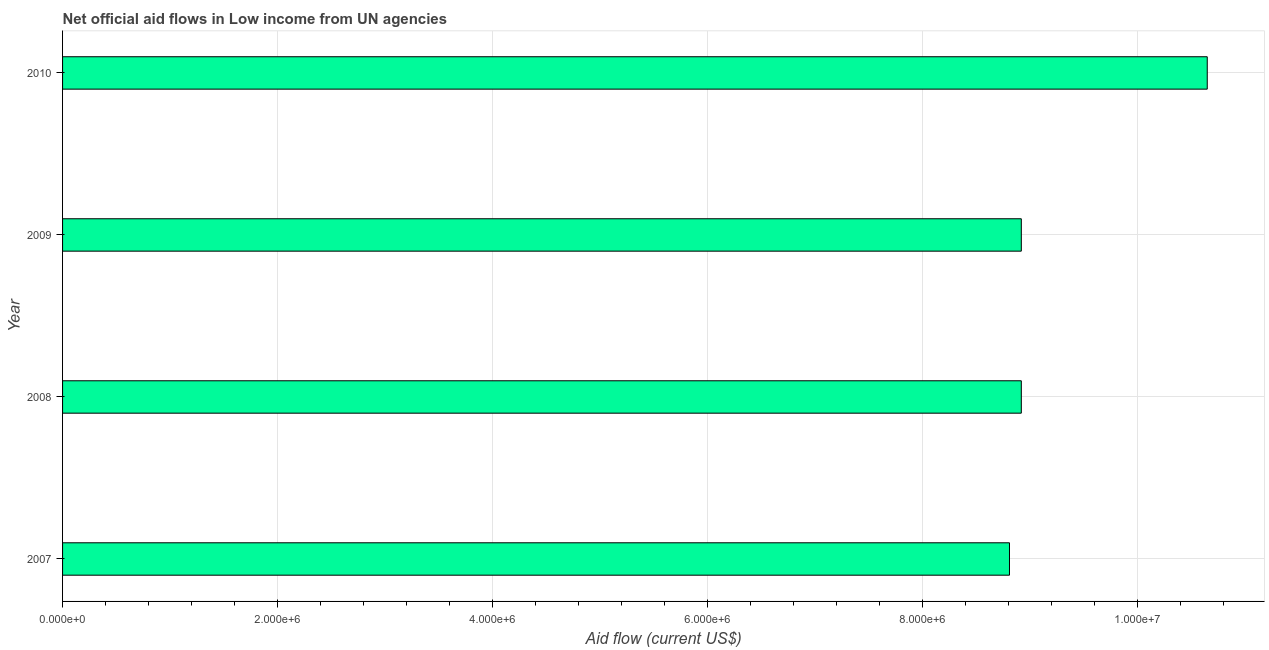What is the title of the graph?
Ensure brevity in your answer.  Net official aid flows in Low income from UN agencies. What is the net official flows from un agencies in 2008?
Offer a terse response. 8.92e+06. Across all years, what is the maximum net official flows from un agencies?
Provide a short and direct response. 1.06e+07. Across all years, what is the minimum net official flows from un agencies?
Provide a succinct answer. 8.81e+06. In which year was the net official flows from un agencies maximum?
Offer a very short reply. 2010. In which year was the net official flows from un agencies minimum?
Offer a terse response. 2007. What is the sum of the net official flows from un agencies?
Ensure brevity in your answer.  3.73e+07. What is the difference between the net official flows from un agencies in 2007 and 2010?
Provide a short and direct response. -1.84e+06. What is the average net official flows from un agencies per year?
Give a very brief answer. 9.32e+06. What is the median net official flows from un agencies?
Your answer should be compact. 8.92e+06. Do a majority of the years between 2009 and 2010 (inclusive) have net official flows from un agencies greater than 8400000 US$?
Give a very brief answer. Yes. What is the ratio of the net official flows from un agencies in 2007 to that in 2010?
Your response must be concise. 0.83. Is the net official flows from un agencies in 2007 less than that in 2010?
Make the answer very short. Yes. What is the difference between the highest and the second highest net official flows from un agencies?
Keep it short and to the point. 1.73e+06. Is the sum of the net official flows from un agencies in 2007 and 2009 greater than the maximum net official flows from un agencies across all years?
Your answer should be compact. Yes. What is the difference between the highest and the lowest net official flows from un agencies?
Your response must be concise. 1.84e+06. In how many years, is the net official flows from un agencies greater than the average net official flows from un agencies taken over all years?
Give a very brief answer. 1. How many bars are there?
Ensure brevity in your answer.  4. What is the Aid flow (current US$) in 2007?
Offer a very short reply. 8.81e+06. What is the Aid flow (current US$) in 2008?
Your answer should be compact. 8.92e+06. What is the Aid flow (current US$) in 2009?
Provide a short and direct response. 8.92e+06. What is the Aid flow (current US$) in 2010?
Ensure brevity in your answer.  1.06e+07. What is the difference between the Aid flow (current US$) in 2007 and 2008?
Provide a short and direct response. -1.10e+05. What is the difference between the Aid flow (current US$) in 2007 and 2009?
Give a very brief answer. -1.10e+05. What is the difference between the Aid flow (current US$) in 2007 and 2010?
Keep it short and to the point. -1.84e+06. What is the difference between the Aid flow (current US$) in 2008 and 2010?
Make the answer very short. -1.73e+06. What is the difference between the Aid flow (current US$) in 2009 and 2010?
Keep it short and to the point. -1.73e+06. What is the ratio of the Aid flow (current US$) in 2007 to that in 2008?
Ensure brevity in your answer.  0.99. What is the ratio of the Aid flow (current US$) in 2007 to that in 2009?
Your response must be concise. 0.99. What is the ratio of the Aid flow (current US$) in 2007 to that in 2010?
Your answer should be very brief. 0.83. What is the ratio of the Aid flow (current US$) in 2008 to that in 2009?
Offer a terse response. 1. What is the ratio of the Aid flow (current US$) in 2008 to that in 2010?
Provide a short and direct response. 0.84. What is the ratio of the Aid flow (current US$) in 2009 to that in 2010?
Give a very brief answer. 0.84. 